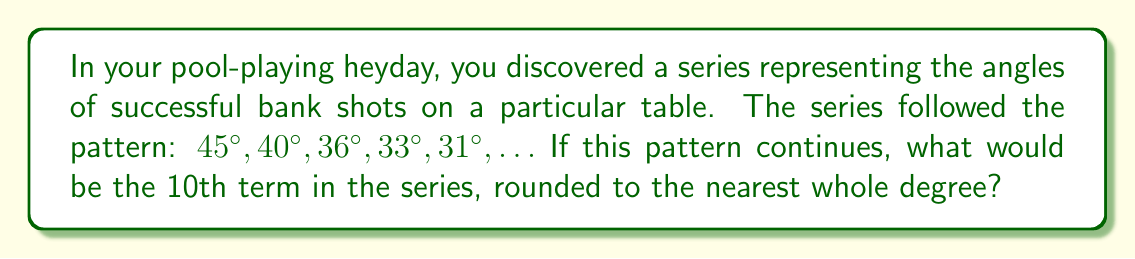Give your solution to this math problem. To solve this problem, let's follow these steps:

1) First, we need to identify the pattern in the series. Let's look at the differences between consecutive terms:

   $45° - 40° = 5°$
   $40° - 36° = 4°$
   $36° - 33° = 3°$
   $33° - 31° = 2°$

2) We can see that the difference is decreasing by 1° each time. This suggests that the series follows the pattern of a harmonic sequence in reverse.

3) In a harmonic sequence, the nth term is given by the formula:

   $$a_n = \frac{1}{\frac{1}{a_1} + (n-1)d}$$

   where $a_1$ is the first term and $d$ is the common difference of the reciprocals.

4) In our case, $a_1 = 45°$ and we need to find $d$:

   $\frac{1}{40} - \frac{1}{45} = \frac{1}{36} - \frac{1}{40} = \frac{1}{33} - \frac{1}{36} = \frac{1}{360}$

   So, $d = \frac{1}{360}$

5) Now we can use the formula to find the 10th term:

   $$a_{10} = \frac{1}{\frac{1}{45} + (10-1)\frac{1}{360}}$$

6) Simplifying:

   $$a_{10} = \frac{1}{\frac{8}{360} + \frac{9}{360}} = \frac{1}{\frac{17}{360}} = \frac{360}{17} \approx 21.1764706°$$

7) Rounding to the nearest whole degree:

   $21.1764706° \approx 21°$
Answer: 21° 